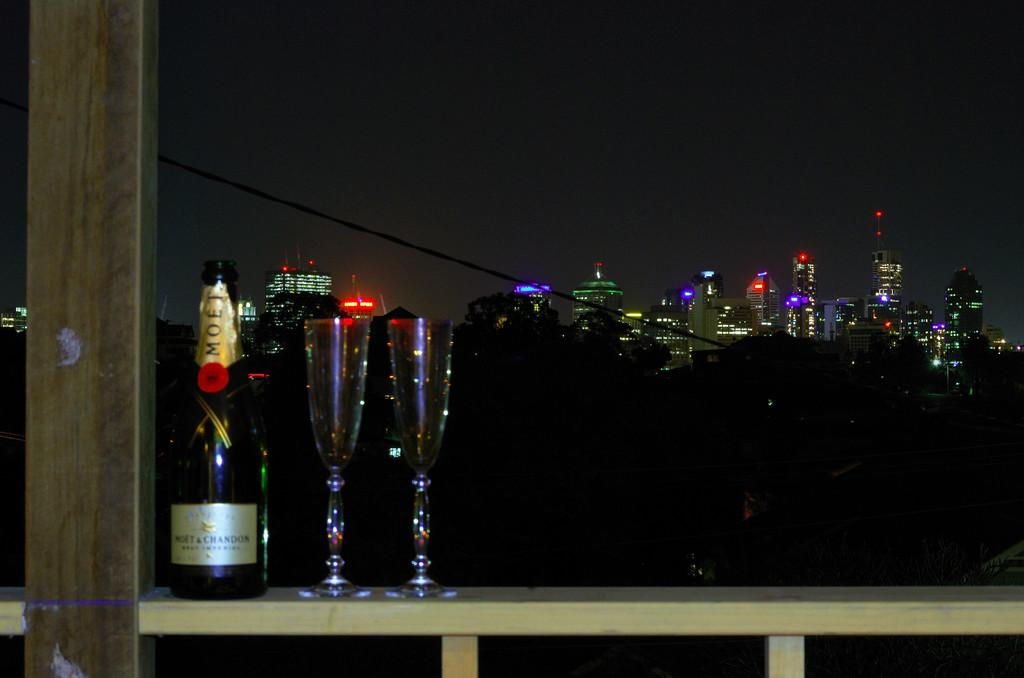<image>
Describe the image concisely. Two champagne flutes are ready for the Moet to be poured. 